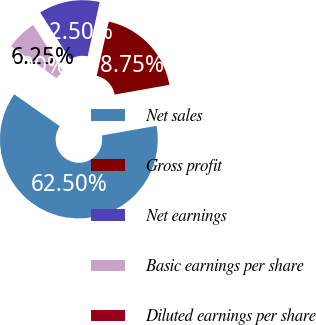Convert chart. <chart><loc_0><loc_0><loc_500><loc_500><pie_chart><fcel>Net sales<fcel>Gross profit<fcel>Net earnings<fcel>Basic earnings per share<fcel>Diluted earnings per share<nl><fcel>62.5%<fcel>18.75%<fcel>12.5%<fcel>6.25%<fcel>0.0%<nl></chart> 